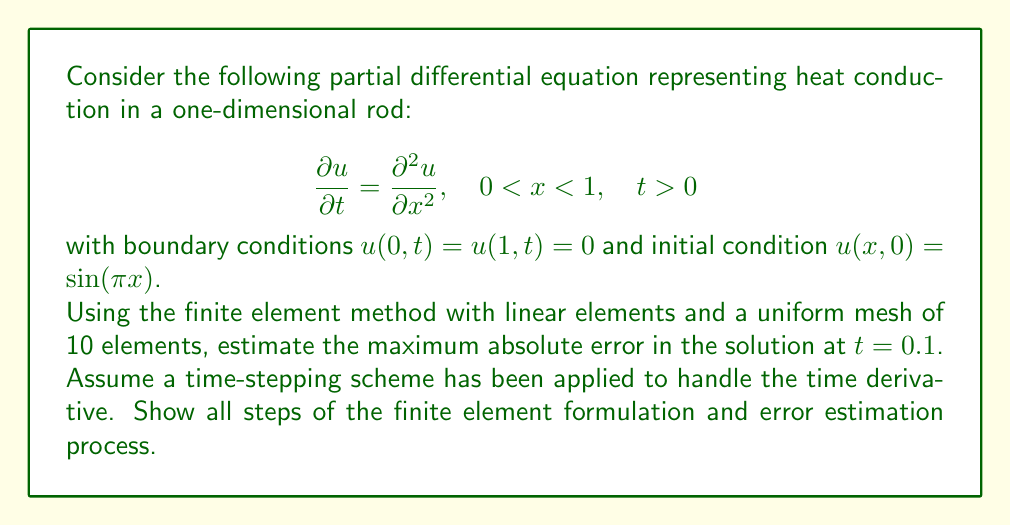What is the answer to this math problem? 1. Weak formulation:
Multiply the PDE by a test function $v$ and integrate over the domain:

$$\int_0^1 \frac{\partial u}{\partial t} v dx = \int_0^1 \frac{\partial^2 u}{\partial x^2} v dx$$

2. Integration by parts:

$$\int_0^1 \frac{\partial u}{\partial t} v dx = -\int_0^1 \frac{\partial u}{\partial x} \frac{\partial v}{\partial x} dx + \left[\frac{\partial u}{\partial x} v\right]_0^1$$

The boundary term vanishes due to the boundary conditions.

3. Finite element discretization:
Divide the domain into 10 elements of length $h = 0.1$. Use linear basis functions $\phi_i(x)$ for $i = 0, 1, ..., 10$.

4. Approximate solution:

$$u(x,t) \approx \sum_{j=1}^9 U_j(t) \phi_j(x)$$

5. Galerkin formulation:
Choose $v = \phi_i(x)$ for $i = 1, ..., 9$:

$$\sum_{j=1}^9 \frac{dU_j}{dt} \int_0^1 \phi_j \phi_i dx = -\sum_{j=1}^9 U_j \int_0^1 \frac{d\phi_j}{dx} \frac{d\phi_i}{dx} dx$$

6. Assembly of mass and stiffness matrices:
Mass matrix $M_{ij} = \int_0^1 \phi_j \phi_i dx$
Stiffness matrix $K_{ij} = \int_0^1 \frac{d\phi_j}{dx} \frac{d\phi_i}{dx} dx$

7. System of ODEs:

$$M \frac{dU}{dt} = -KU$$

8. Time-stepping:
Apply a suitable time-stepping scheme (e.g., backward Euler) to solve the system of ODEs.

9. Error estimation:
Use a posteriori error estimator based on the residual:

$$\eta_K^2 = h_K^2 \|R_K\|_{L^2(K)}^2 + \frac{1}{2} h_E \|J_E\|_{L^2(E)}^2$$

where $R_K$ is the element residual and $J_E$ is the jump in the normal derivative across element edges.

10. Compute the error estimator for each element and sum to get the global error estimate.

11. The maximum absolute error is approximately the square root of the sum of squared element error estimates.
Answer: $\sqrt{\sum_{K} \eta_K^2}$ 